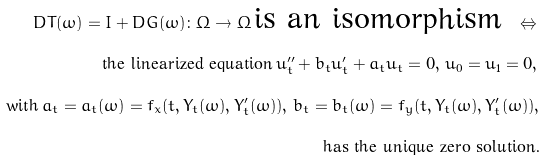<formula> <loc_0><loc_0><loc_500><loc_500>D T ( \omega ) = I + D G ( \omega ) \colon \Omega \to \Omega \, \text {is an isomorphism } \, \Leftrightarrow \, \\ \text {the linearized equation} \, u _ { t } ^ { \prime \prime } + b _ { t } u _ { t } ^ { \prime } + a _ { t } u _ { t } = 0 , \, u _ { 0 } = u _ { 1 } = 0 , \, \\ \text {with} \, a _ { t } = a _ { t } ( \omega ) = f _ { x } ( t , Y _ { t } ( \omega ) , Y _ { t } ^ { \prime } ( \omega ) ) , \, b _ { t } = b _ { t } ( \omega ) = f _ { y } ( t , Y _ { t } ( \omega ) , Y _ { t } ^ { \prime } ( \omega ) ) , \\ \text {has the unique zero solution.}</formula> 